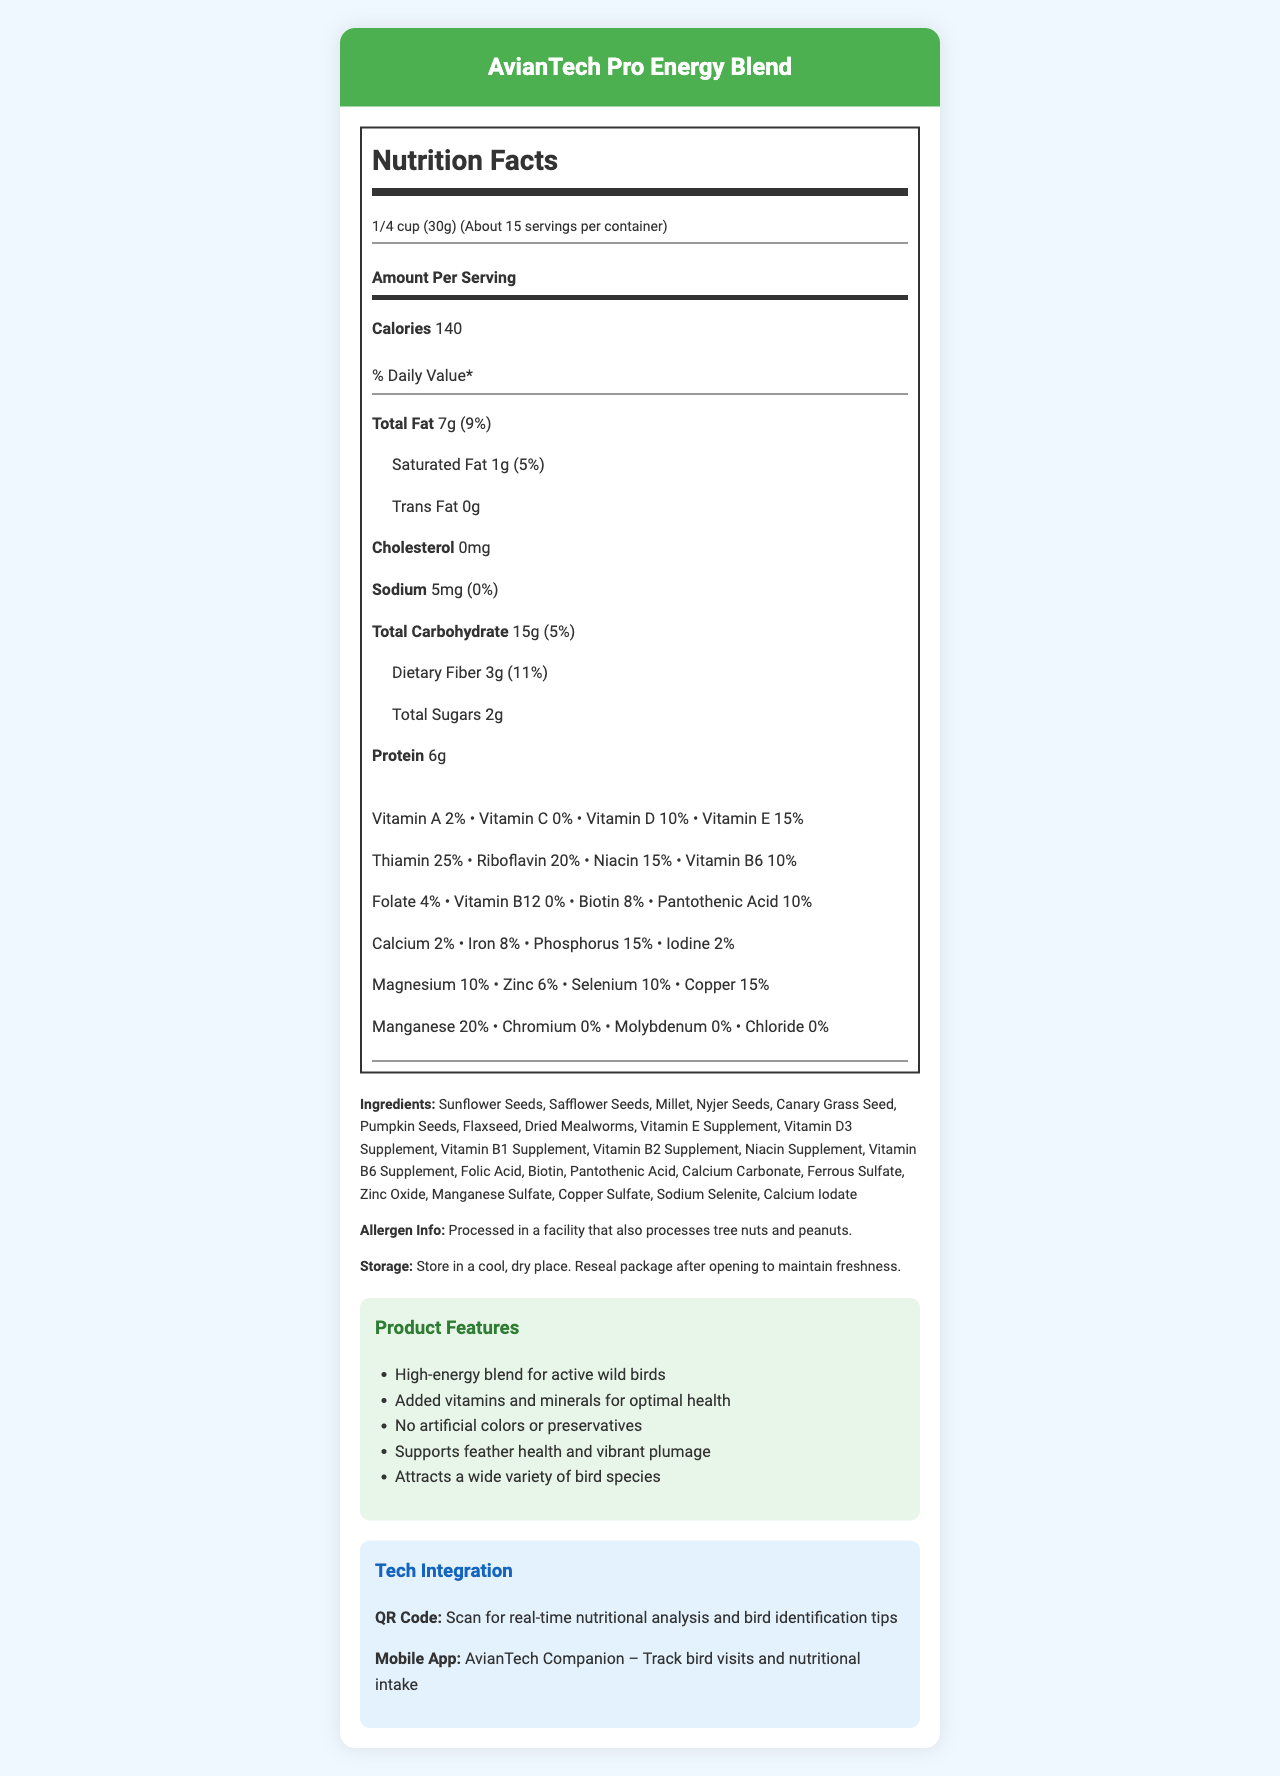what is the serving size? The serving size is stated clearly on the document as "1/4 cup (30g)".
Answer: 1/4 cup (30g) how many calories are in one serving? The nutrition label specifies that one serving contains 140 calories.
Answer: 140 what is the total fat content per serving? The label indicates "Total Fat" as 7g per serving.
Answer: 7g which vitamins are included in the bird seed mix? List at least three. The label specifies various vitamins, including Vitamin A, D, and E among others.
Answer: Vitamin A, Vitamin D, Vitamin E what is the recommended storage instruction for the product? This information is provided under the "Storage" section of the document.
Answer: Store in a cool, dry place. Reseal package after opening to maintain freshness. which bird species is this seed mix suitable for? A. Sparrows B. Chickadees C. Pigeons D. Eagles According to the document, the seed mix is suitable for Chickadees along with other bird species like Finches and Woodpeckers.
Answer: B. Chickadees how many servings are approximately in one container? A. 10 B. 15 C. 20 D. 25 The document states "Servings Per Container: About 15".
Answer: B. 15 does the product contain artificial colors or preservatives? The document highlights "No artificial colors or preservatives" as one of its features.
Answer: No is the packaging of this product eco-friendly? The document mentions that the packaging is made from 100% post-consumer recycled materials, indicating it is eco-friendly.
Answer: Yes summarize the main features of the AvianTech Pro Energy Blend. This summary captures the overall essence and features of the product as described in the document.
Answer: The AvianTech Pro Energy Blend is a high-energy bird seed mix designed for active wild birds. It includes added vitamins and minerals for optimal health, contains no artificial colors or preservatives, supports feather health and vibrant plumage, and attracts a wide variety of bird species. It is compatible with various feeder types and offers tech integration through a QR code and mobile app. The packaging is eco-friendly. what is the purpose of the QR code included on the packaging? The document states that the QR code can be scanned for real-time nutritional analysis and bird identification tips.
Answer: Scan for real-time nutritional analysis and bird identification tips does the product contain any peanuts? While the allergen info indicates it is processed in a facility that processes peanuts, the document does not explicitly state whether the product contains peanuts.
Answer: Not enough information identify two minerals in the bird seed mix that promote health. The document lists multiple minerals, including Calcium and Iron, which promote health.
Answer: Calcium, Iron what feature of the seed mix supports feather health? One of the features listed in the document is "Supports feather health and vibrant plumage".
Answer: Supports feather health and vibrant plumage how much protein does one serving of the seed mix provide? The document specifies that one serving contains 6g of protein.
Answer: 6g is the product suitable for use in squirrel-proof feeders? The document includes squirrel-proof feeders in the list of compatible feeders.
Answer: Yes what additional technology is integrated with the product? A. GPS Tracker B. Bird Identification Tips C. Webcam D. Sound Recorder The document mentions real-time nutritional analysis and bird identification tips via a QR code and a mobile app.
Answer: B. Bird Identification Tips is there any trans fat in the product? The nutrition label lists "Trans Fat" as 0g, indicating there is no trans fat in the product.
Answer: No 